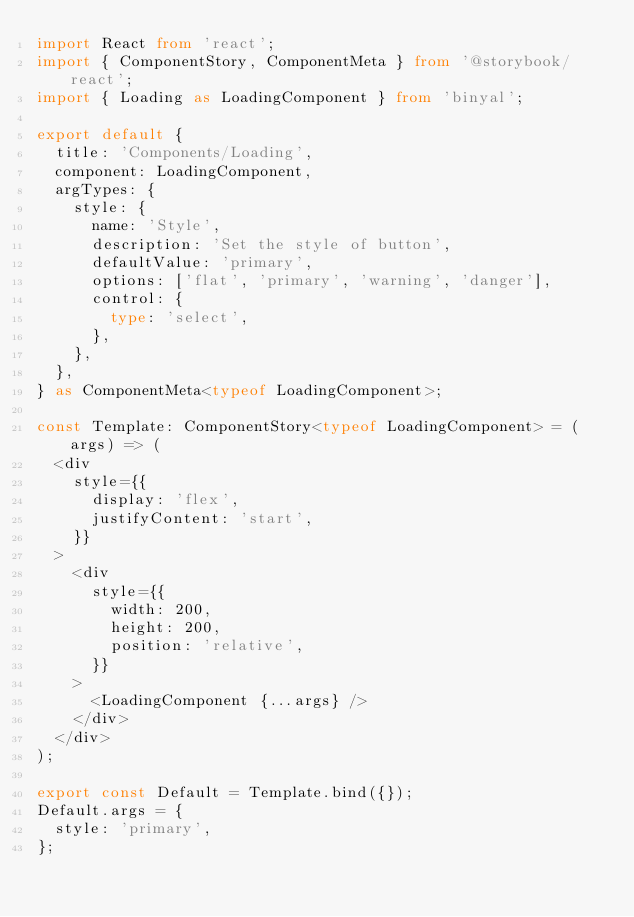<code> <loc_0><loc_0><loc_500><loc_500><_TypeScript_>import React from 'react';
import { ComponentStory, ComponentMeta } from '@storybook/react';
import { Loading as LoadingComponent } from 'binyal';

export default {
  title: 'Components/Loading',
  component: LoadingComponent,
  argTypes: {
    style: {
      name: 'Style',
      description: 'Set the style of button',
      defaultValue: 'primary',
      options: ['flat', 'primary', 'warning', 'danger'],
      control: {
        type: 'select',
      },
    },
  },
} as ComponentMeta<typeof LoadingComponent>;

const Template: ComponentStory<typeof LoadingComponent> = (args) => (
  <div
    style={{
      display: 'flex',
      justifyContent: 'start',
    }}
  >
    <div
      style={{
        width: 200,
        height: 200,
        position: 'relative',
      }}
    >
      <LoadingComponent {...args} />
    </div>
  </div>
);

export const Default = Template.bind({});
Default.args = {
  style: 'primary',
};
</code> 